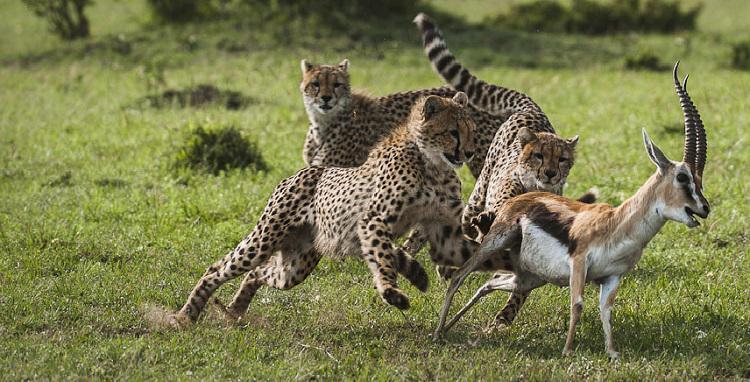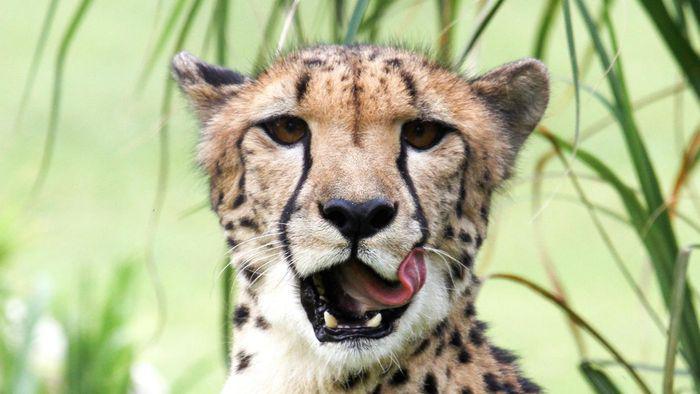The first image is the image on the left, the second image is the image on the right. For the images shown, is this caption "In one of the images, there is at least one cheetah cub." true? Answer yes or no. No. The first image is the image on the left, the second image is the image on the right. Assess this claim about the two images: "One image includes an adult cheetah with its tongue out and no prey present, and the other image shows a gazelle preyed on by at least one cheetah.". Correct or not? Answer yes or no. Yes. 